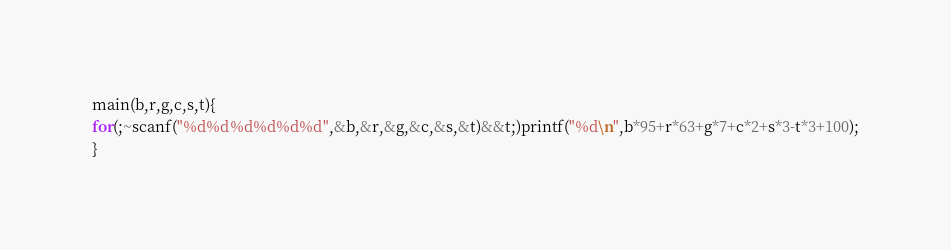Convert code to text. <code><loc_0><loc_0><loc_500><loc_500><_C_>main(b,r,g,c,s,t){
for(;~scanf("%d%d%d%d%d%d",&b,&r,&g,&c,&s,&t)&&t;)printf("%d\n",b*95+r*63+g*7+c*2+s*3-t*3+100);
}</code> 